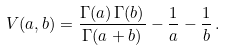<formula> <loc_0><loc_0><loc_500><loc_500>\ V ( a , b ) = \frac { \Gamma ( a ) \, \Gamma ( b ) } { \Gamma ( a + b ) } - \frac { 1 } { a } - \frac { 1 } { b } \, .</formula> 